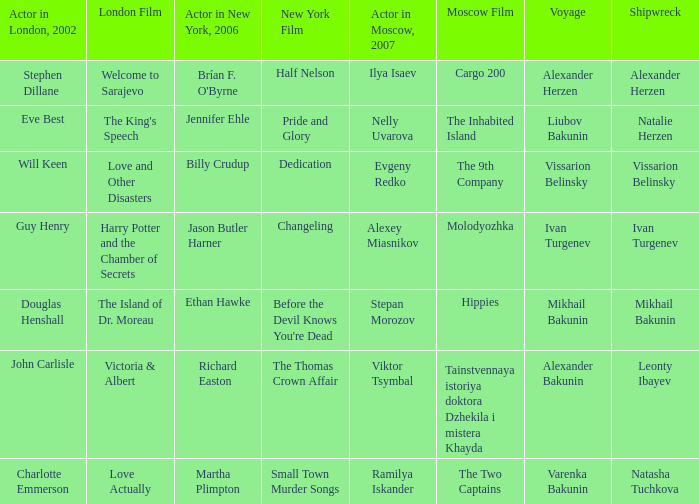Who was the actor in Moscow who did the part done by John Carlisle in London in 2002? Viktor Tsymbal. Would you be able to parse every entry in this table? {'header': ['Actor in London, 2002', 'London Film', 'Actor in New York, 2006', 'New York Film', 'Actor in Moscow, 2007', 'Moscow Film', 'Voyage', 'Shipwreck'], 'rows': [['Stephen Dillane', 'Welcome to Sarajevo', "Brían F. O'Byrne", 'Half Nelson', 'Ilya Isaev', 'Cargo 200', 'Alexander Herzen', 'Alexander Herzen'], ['Eve Best', "The King's Speech", 'Jennifer Ehle', 'Pride and Glory', 'Nelly Uvarova', 'The Inhabited Island', 'Liubov Bakunin', 'Natalie Herzen'], ['Will Keen', 'Love and Other Disasters', 'Billy Crudup', 'Dedication', 'Evgeny Redko', 'The 9th Company', 'Vissarion Belinsky', 'Vissarion Belinsky'], ['Guy Henry', 'Harry Potter and the Chamber of Secrets', 'Jason Butler Harner', 'Changeling', 'Alexey Miasnikov', 'Molodyozhka', 'Ivan Turgenev', 'Ivan Turgenev'], ['Douglas Henshall', 'The Island of Dr. Moreau', 'Ethan Hawke', "Before the Devil Knows You're Dead", 'Stepan Morozov', 'Hippies', 'Mikhail Bakunin', 'Mikhail Bakunin'], ['John Carlisle', 'Victoria & Albert', 'Richard Easton', 'The Thomas Crown Affair', 'Viktor Tsymbal', 'Tainstvennaya istoriya doktora Dzhekila i mistera Khayda', 'Alexander Bakunin', 'Leonty Ibayev'], ['Charlotte Emmerson', 'Love Actually', 'Martha Plimpton', 'Small Town Murder Songs', 'Ramilya Iskander', 'The Two Captains', 'Varenka Bakunin', 'Natasha Tuchkova']]} 